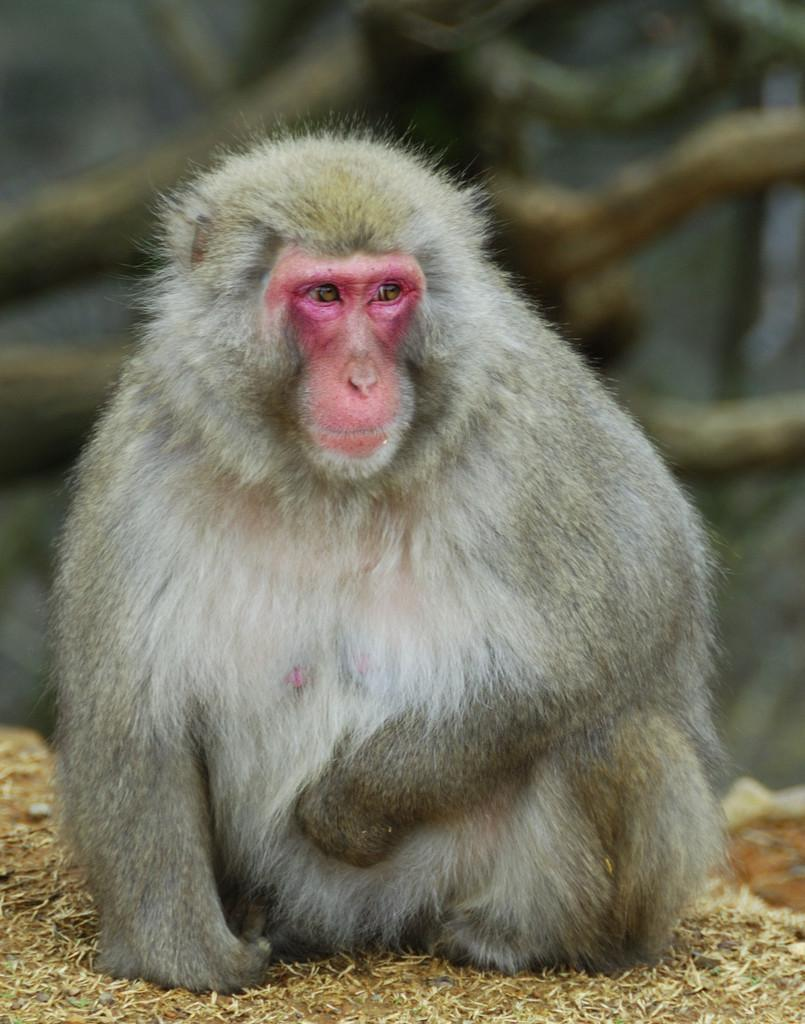What animal is in the picture? There is a monkey in the picture. What is the monkey doing in the picture? The monkey is sitting. Can you describe the background of the image? The background of the image is blurry. Where is the quiver located in the image? There is no quiver present in the image. What type of food is being served in the lunchroom in the image? There is no lunchroom present in the image. 